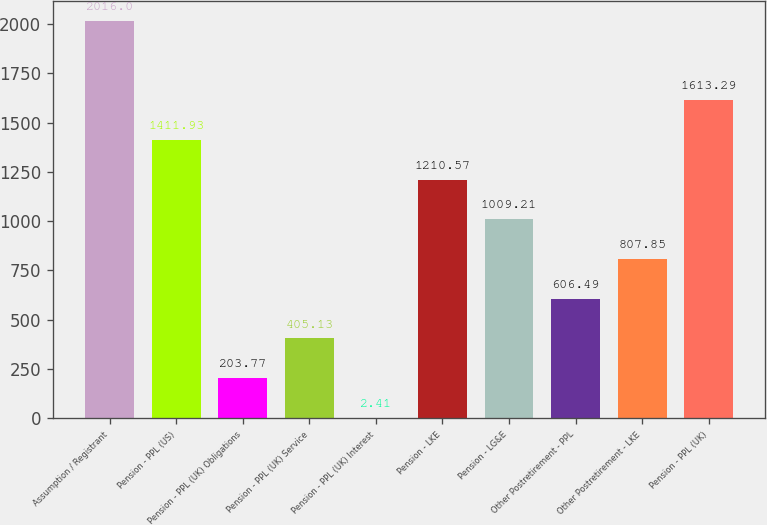Convert chart to OTSL. <chart><loc_0><loc_0><loc_500><loc_500><bar_chart><fcel>Assumption / Registrant<fcel>Pension - PPL (US)<fcel>Pension - PPL (UK) Obligations<fcel>Pension - PPL (UK) Service<fcel>Pension - PPL (UK) Interest<fcel>Pension - LKE<fcel>Pension - LG&E<fcel>Other Postretirement - PPL<fcel>Other Postretirement - LKE<fcel>Pension - PPL (UK)<nl><fcel>2016<fcel>1411.93<fcel>203.77<fcel>405.13<fcel>2.41<fcel>1210.57<fcel>1009.21<fcel>606.49<fcel>807.85<fcel>1613.29<nl></chart> 